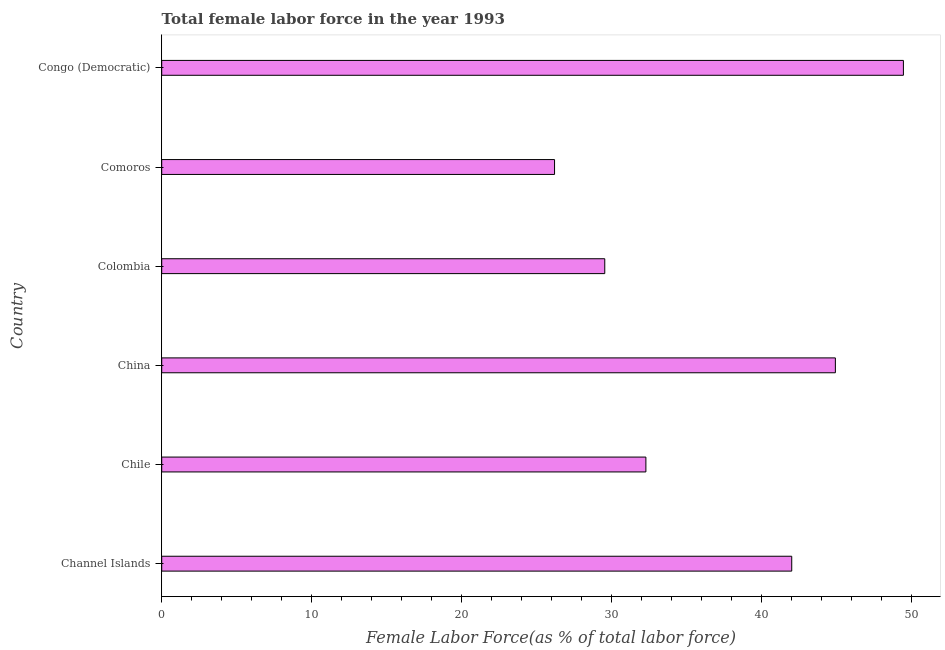Does the graph contain any zero values?
Provide a succinct answer. No. What is the title of the graph?
Offer a terse response. Total female labor force in the year 1993. What is the label or title of the X-axis?
Your response must be concise. Female Labor Force(as % of total labor force). What is the total female labor force in Congo (Democratic)?
Provide a short and direct response. 49.45. Across all countries, what is the maximum total female labor force?
Offer a terse response. 49.45. Across all countries, what is the minimum total female labor force?
Your answer should be compact. 26.19. In which country was the total female labor force maximum?
Your answer should be very brief. Congo (Democratic). In which country was the total female labor force minimum?
Keep it short and to the point. Comoros. What is the sum of the total female labor force?
Provide a succinct answer. 224.39. What is the difference between the total female labor force in China and Colombia?
Offer a terse response. 15.38. What is the average total female labor force per country?
Offer a terse response. 37.4. What is the median total female labor force?
Ensure brevity in your answer.  37.14. In how many countries, is the total female labor force greater than 24 %?
Make the answer very short. 6. What is the ratio of the total female labor force in Comoros to that in Congo (Democratic)?
Your response must be concise. 0.53. Is the total female labor force in Comoros less than that in Congo (Democratic)?
Ensure brevity in your answer.  Yes. What is the difference between the highest and the second highest total female labor force?
Provide a short and direct response. 4.54. Is the sum of the total female labor force in China and Congo (Democratic) greater than the maximum total female labor force across all countries?
Offer a terse response. Yes. What is the difference between the highest and the lowest total female labor force?
Keep it short and to the point. 23.26. In how many countries, is the total female labor force greater than the average total female labor force taken over all countries?
Offer a terse response. 3. How many bars are there?
Your answer should be compact. 6. What is the Female Labor Force(as % of total labor force) in Channel Islands?
Offer a very short reply. 42.01. What is the Female Labor Force(as % of total labor force) in Chile?
Provide a succinct answer. 32.28. What is the Female Labor Force(as % of total labor force) in China?
Your response must be concise. 44.92. What is the Female Labor Force(as % of total labor force) of Colombia?
Your response must be concise. 29.54. What is the Female Labor Force(as % of total labor force) in Comoros?
Your response must be concise. 26.19. What is the Female Labor Force(as % of total labor force) in Congo (Democratic)?
Offer a terse response. 49.45. What is the difference between the Female Labor Force(as % of total labor force) in Channel Islands and Chile?
Provide a short and direct response. 9.72. What is the difference between the Female Labor Force(as % of total labor force) in Channel Islands and China?
Your response must be concise. -2.91. What is the difference between the Female Labor Force(as % of total labor force) in Channel Islands and Colombia?
Provide a short and direct response. 12.47. What is the difference between the Female Labor Force(as % of total labor force) in Channel Islands and Comoros?
Ensure brevity in your answer.  15.81. What is the difference between the Female Labor Force(as % of total labor force) in Channel Islands and Congo (Democratic)?
Provide a succinct answer. -7.45. What is the difference between the Female Labor Force(as % of total labor force) in Chile and China?
Your answer should be very brief. -12.63. What is the difference between the Female Labor Force(as % of total labor force) in Chile and Colombia?
Your answer should be very brief. 2.74. What is the difference between the Female Labor Force(as % of total labor force) in Chile and Comoros?
Your response must be concise. 6.09. What is the difference between the Female Labor Force(as % of total labor force) in Chile and Congo (Democratic)?
Give a very brief answer. -17.17. What is the difference between the Female Labor Force(as % of total labor force) in China and Colombia?
Offer a very short reply. 15.38. What is the difference between the Female Labor Force(as % of total labor force) in China and Comoros?
Ensure brevity in your answer.  18.72. What is the difference between the Female Labor Force(as % of total labor force) in China and Congo (Democratic)?
Offer a very short reply. -4.54. What is the difference between the Female Labor Force(as % of total labor force) in Colombia and Comoros?
Offer a terse response. 3.35. What is the difference between the Female Labor Force(as % of total labor force) in Colombia and Congo (Democratic)?
Your answer should be compact. -19.91. What is the difference between the Female Labor Force(as % of total labor force) in Comoros and Congo (Democratic)?
Offer a terse response. -23.26. What is the ratio of the Female Labor Force(as % of total labor force) in Channel Islands to that in Chile?
Your answer should be very brief. 1.3. What is the ratio of the Female Labor Force(as % of total labor force) in Channel Islands to that in China?
Make the answer very short. 0.94. What is the ratio of the Female Labor Force(as % of total labor force) in Channel Islands to that in Colombia?
Offer a terse response. 1.42. What is the ratio of the Female Labor Force(as % of total labor force) in Channel Islands to that in Comoros?
Offer a very short reply. 1.6. What is the ratio of the Female Labor Force(as % of total labor force) in Channel Islands to that in Congo (Democratic)?
Offer a terse response. 0.85. What is the ratio of the Female Labor Force(as % of total labor force) in Chile to that in China?
Your answer should be compact. 0.72. What is the ratio of the Female Labor Force(as % of total labor force) in Chile to that in Colombia?
Your response must be concise. 1.09. What is the ratio of the Female Labor Force(as % of total labor force) in Chile to that in Comoros?
Offer a very short reply. 1.23. What is the ratio of the Female Labor Force(as % of total labor force) in Chile to that in Congo (Democratic)?
Give a very brief answer. 0.65. What is the ratio of the Female Labor Force(as % of total labor force) in China to that in Colombia?
Ensure brevity in your answer.  1.52. What is the ratio of the Female Labor Force(as % of total labor force) in China to that in Comoros?
Offer a terse response. 1.72. What is the ratio of the Female Labor Force(as % of total labor force) in China to that in Congo (Democratic)?
Provide a short and direct response. 0.91. What is the ratio of the Female Labor Force(as % of total labor force) in Colombia to that in Comoros?
Offer a terse response. 1.13. What is the ratio of the Female Labor Force(as % of total labor force) in Colombia to that in Congo (Democratic)?
Your answer should be compact. 0.6. What is the ratio of the Female Labor Force(as % of total labor force) in Comoros to that in Congo (Democratic)?
Your answer should be very brief. 0.53. 